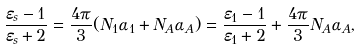Convert formula to latex. <formula><loc_0><loc_0><loc_500><loc_500>\frac { \varepsilon _ { s } - 1 } { \varepsilon _ { s } + 2 } = \frac { 4 \pi } { 3 } ( N _ { 1 } \alpha _ { 1 } + N _ { A } \alpha _ { A } ) = \frac { \varepsilon _ { 1 } - 1 } { \varepsilon _ { 1 } + 2 } + \frac { 4 \pi } { 3 } N _ { A } \alpha _ { A } ,</formula> 